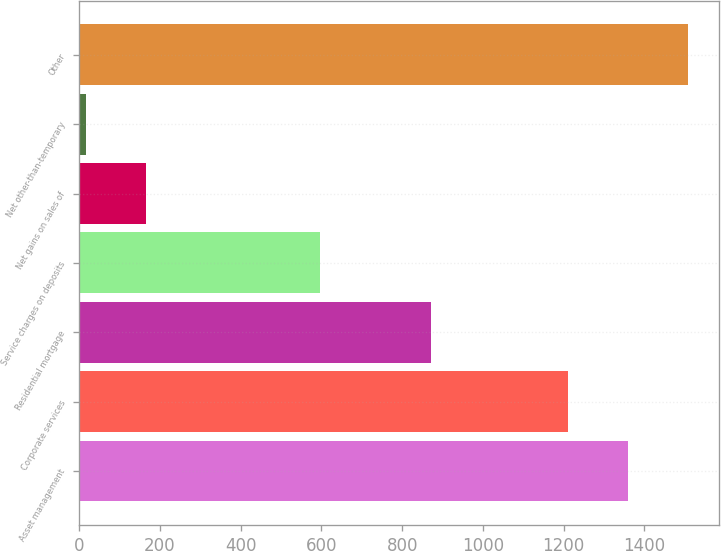Convert chart to OTSL. <chart><loc_0><loc_0><loc_500><loc_500><bar_chart><fcel>Asset management<fcel>Corporate services<fcel>Residential mortgage<fcel>Service charges on deposits<fcel>Net gains on sales of<fcel>Net other-than-temporary<fcel>Other<nl><fcel>1359.3<fcel>1210<fcel>871<fcel>597<fcel>165.3<fcel>16<fcel>1509<nl></chart> 